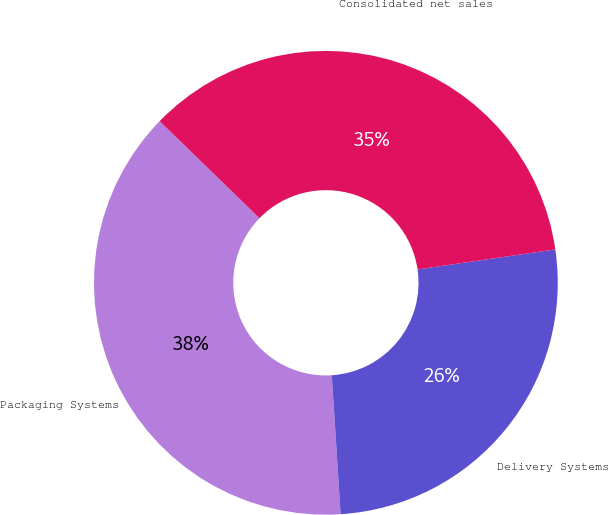Convert chart. <chart><loc_0><loc_0><loc_500><loc_500><pie_chart><fcel>Packaging Systems<fcel>Delivery Systems<fcel>Consolidated net sales<nl><fcel>38.29%<fcel>26.29%<fcel>35.43%<nl></chart> 